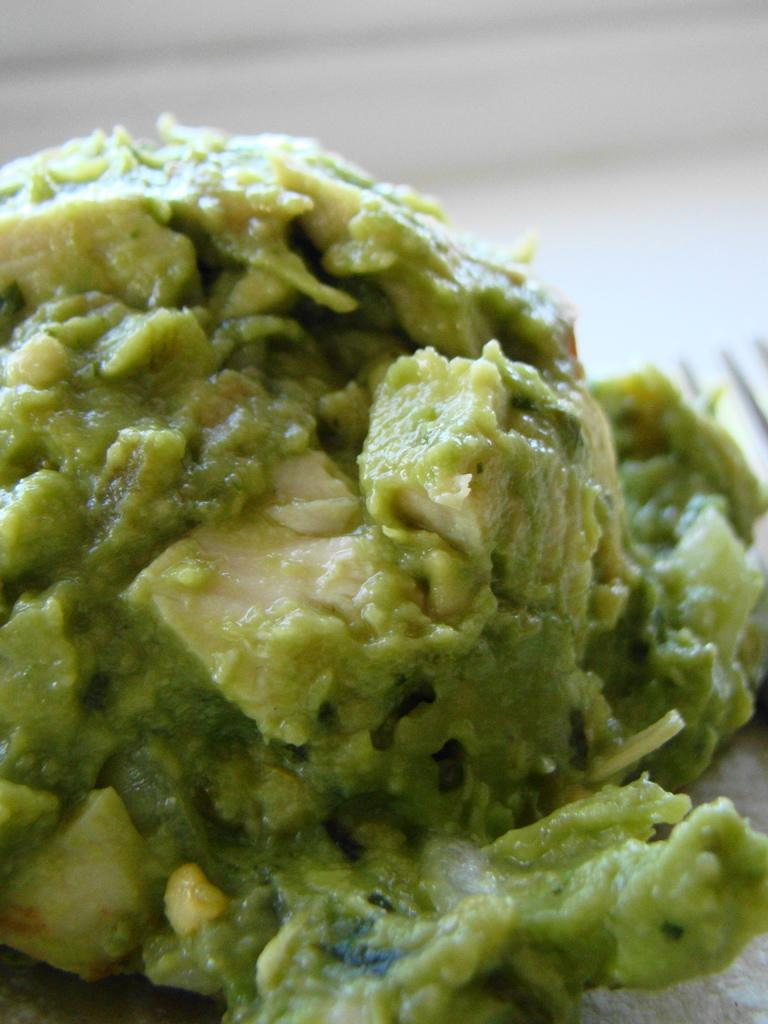What can be seen in the image? There is food in the image. Can you describe the background of the image? The background of the image is blurry. What letter does the son give to his dad in the image? There is no letter, son, or dad present in the image; it only features food and a blurry background. 